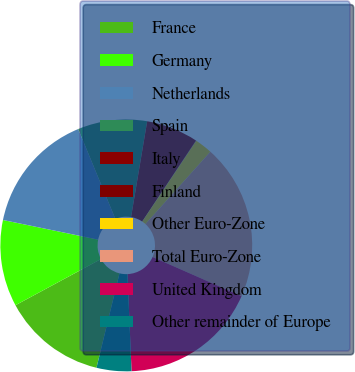<chart> <loc_0><loc_0><loc_500><loc_500><pie_chart><fcel>France<fcel>Germany<fcel>Netherlands<fcel>Spain<fcel>Italy<fcel>Finland<fcel>Other Euro-Zone<fcel>Total Euro-Zone<fcel>United Kingdom<fcel>Other remainder of Europe<nl><fcel>13.32%<fcel>11.11%<fcel>15.53%<fcel>8.89%<fcel>6.68%<fcel>0.05%<fcel>2.26%<fcel>19.95%<fcel>17.74%<fcel>4.47%<nl></chart> 